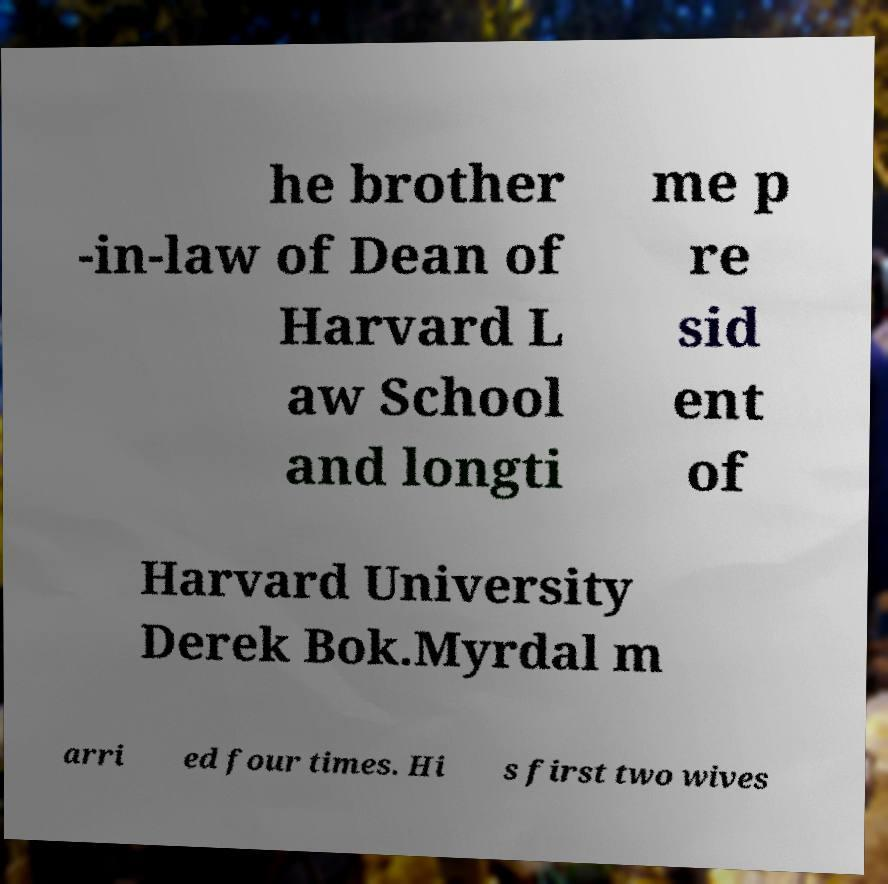There's text embedded in this image that I need extracted. Can you transcribe it verbatim? he brother -in-law of Dean of Harvard L aw School and longti me p re sid ent of Harvard University Derek Bok.Myrdal m arri ed four times. Hi s first two wives 